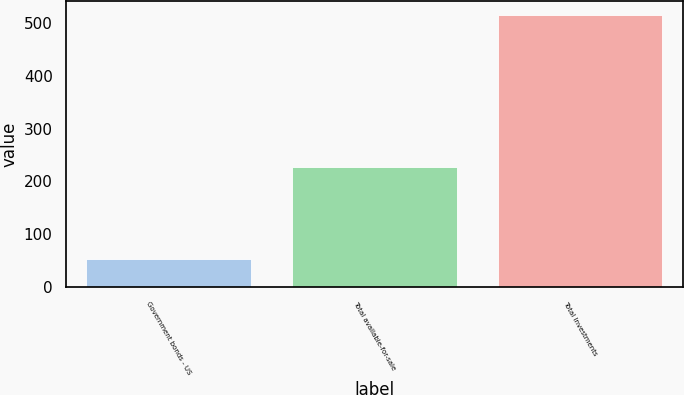Convert chart. <chart><loc_0><loc_0><loc_500><loc_500><bar_chart><fcel>Government bonds - US<fcel>Total available-for-sale<fcel>Total Investments<nl><fcel>52.1<fcel>226.5<fcel>515.7<nl></chart> 